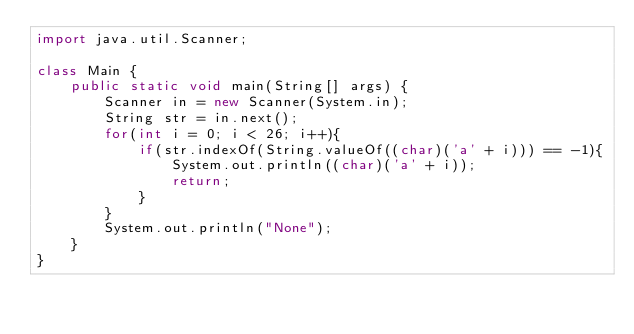Convert code to text. <code><loc_0><loc_0><loc_500><loc_500><_Java_>import java.util.Scanner;

class Main {
    public static void main(String[] args) {
        Scanner in = new Scanner(System.in);
        String str = in.next();
        for(int i = 0; i < 26; i++){
            if(str.indexOf(String.valueOf((char)('a' + i))) == -1){
                System.out.println((char)('a' + i));
                return;
            }
        }
        System.out.println("None");
    }
}
</code> 